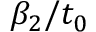Convert formula to latex. <formula><loc_0><loc_0><loc_500><loc_500>\beta _ { 2 } / t _ { 0 }</formula> 